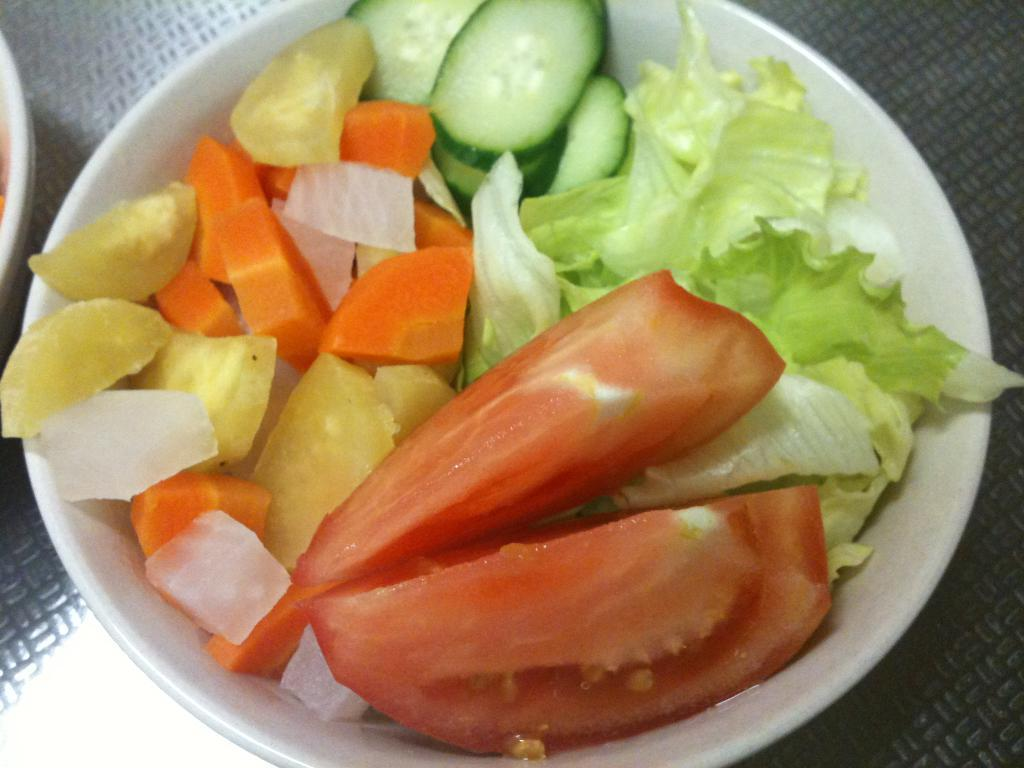What color is the bowl that is visible in the image? The bowl in the image is white. What is inside the bowl? The bowl is filled with food items. What type of lettuce is visible in the image? There is no lettuce present in the image. Is there a ring on the table next to the bowl? There is no mention of a ring or a table in the provided facts, so we cannot determine if there is a ring present in the image. 